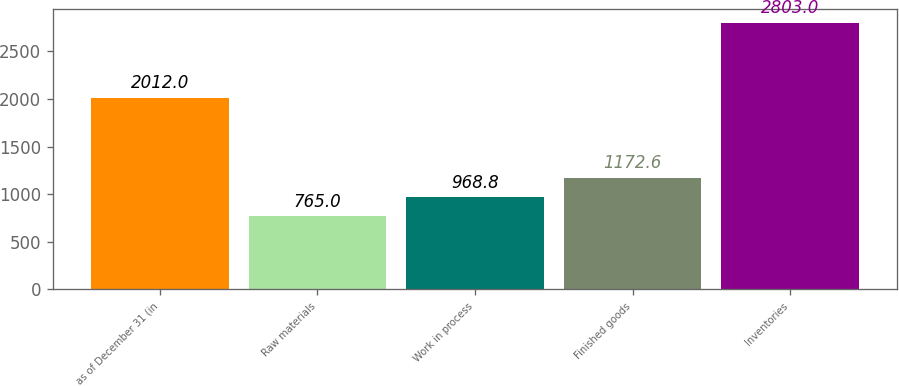Convert chart. <chart><loc_0><loc_0><loc_500><loc_500><bar_chart><fcel>as of December 31 (in<fcel>Raw materials<fcel>Work in process<fcel>Finished goods<fcel>Inventories<nl><fcel>2012<fcel>765<fcel>968.8<fcel>1172.6<fcel>2803<nl></chart> 